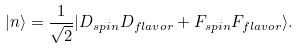<formula> <loc_0><loc_0><loc_500><loc_500>| n \rangle = \frac { 1 } { \sqrt { 2 } } | D _ { s p i n } D _ { f l a v o r } + F _ { s p i n } F _ { f l a v o r } \rangle .</formula> 